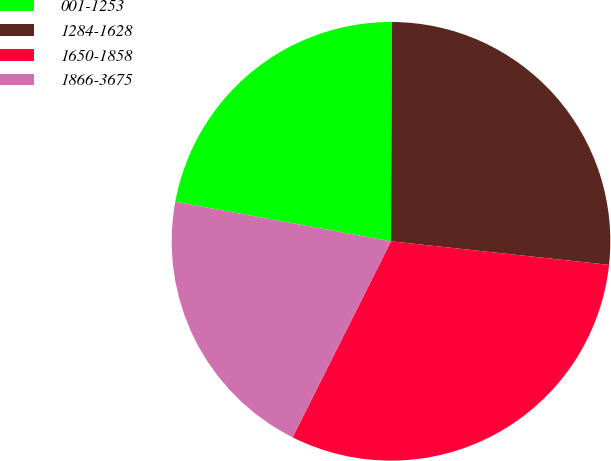Convert chart. <chart><loc_0><loc_0><loc_500><loc_500><pie_chart><fcel>001-1253<fcel>1284-1628<fcel>1650-1858<fcel>1866-3675<nl><fcel>22.19%<fcel>26.64%<fcel>30.69%<fcel>20.48%<nl></chart> 